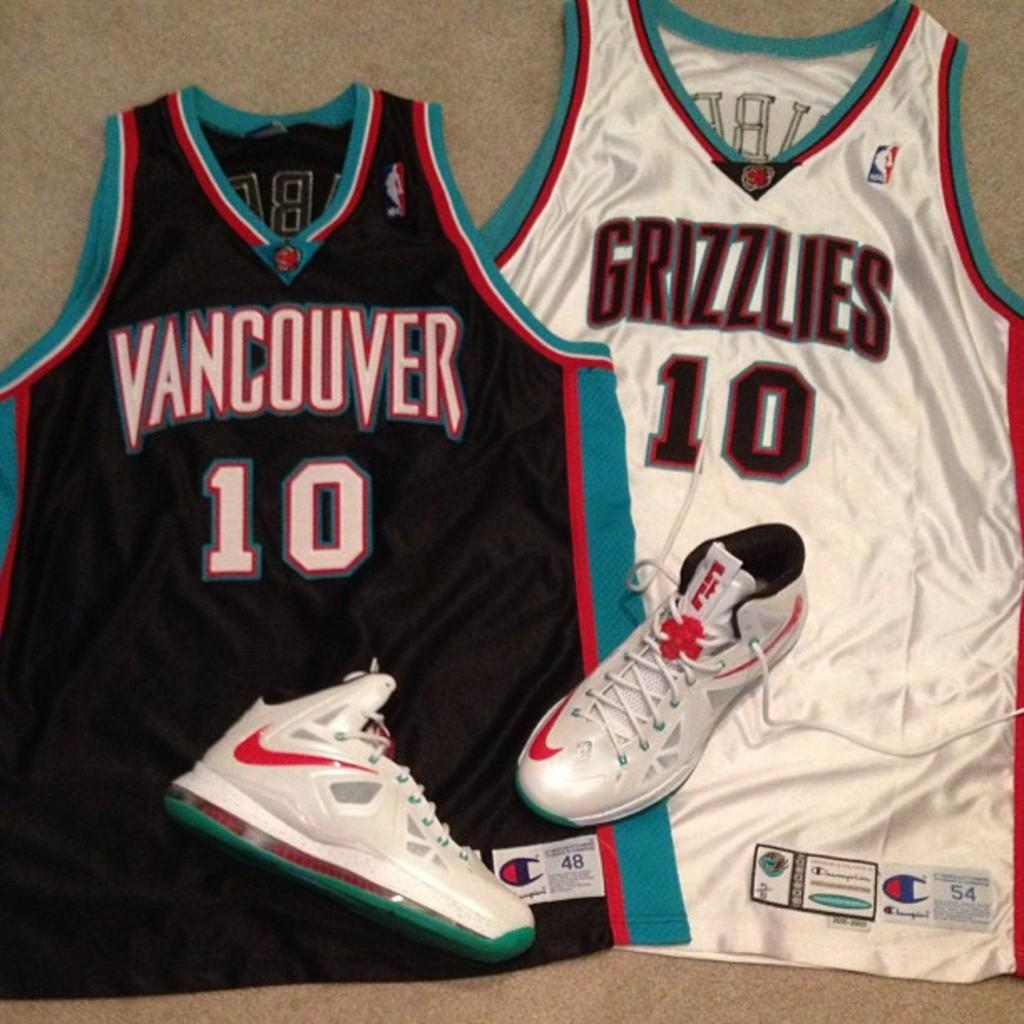Provide a one-sentence caption for the provided image. Two Vancouver Grizzles jerseys number 10 with a pair of Nike shoes on top. 